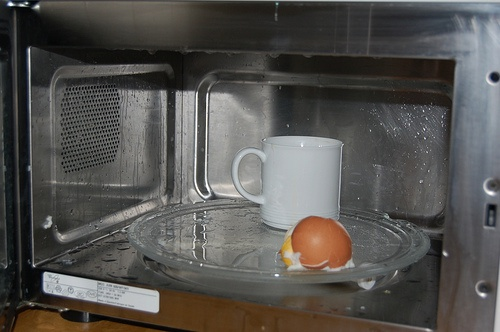Describe the objects in this image and their specific colors. I can see microwave in gray, black, darkgray, and maroon tones and cup in black, darkgray, gray, and lightgray tones in this image. 